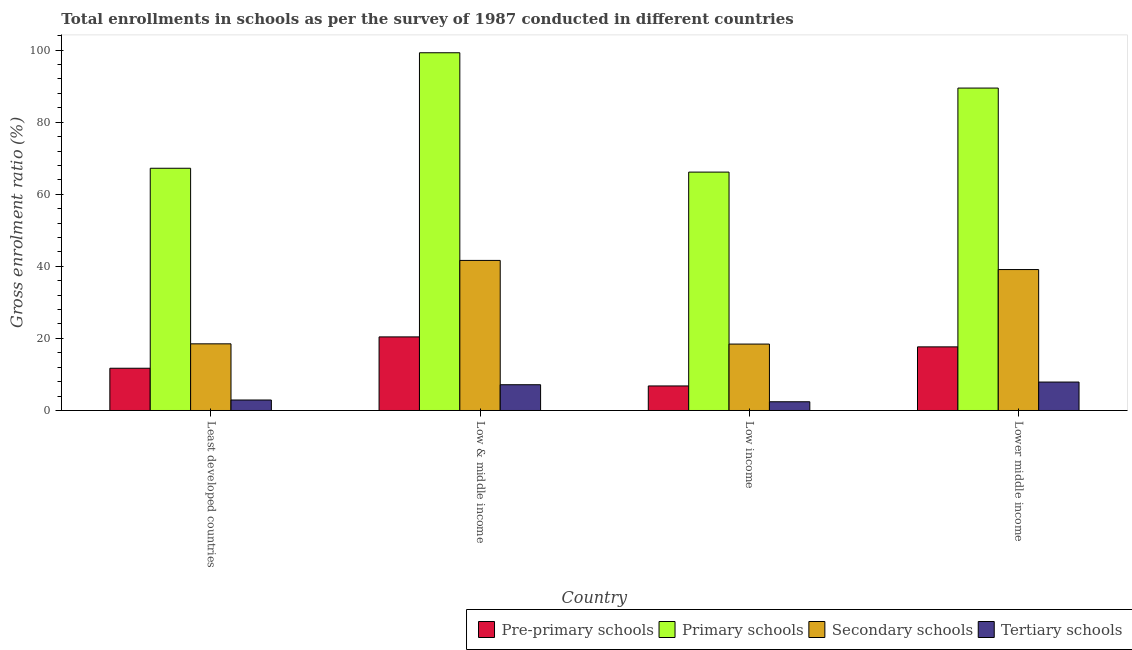What is the gross enrolment ratio in primary schools in Lower middle income?
Offer a terse response. 89.47. Across all countries, what is the maximum gross enrolment ratio in primary schools?
Provide a succinct answer. 99.26. Across all countries, what is the minimum gross enrolment ratio in primary schools?
Your answer should be compact. 66.15. In which country was the gross enrolment ratio in tertiary schools maximum?
Your answer should be compact. Lower middle income. What is the total gross enrolment ratio in primary schools in the graph?
Make the answer very short. 322.1. What is the difference between the gross enrolment ratio in pre-primary schools in Least developed countries and that in Low & middle income?
Provide a short and direct response. -8.7. What is the difference between the gross enrolment ratio in secondary schools in Low & middle income and the gross enrolment ratio in tertiary schools in Least developed countries?
Offer a terse response. 38.74. What is the average gross enrolment ratio in secondary schools per country?
Offer a very short reply. 29.42. What is the difference between the gross enrolment ratio in tertiary schools and gross enrolment ratio in pre-primary schools in Low & middle income?
Make the answer very short. -13.27. In how many countries, is the gross enrolment ratio in tertiary schools greater than 68 %?
Keep it short and to the point. 0. What is the ratio of the gross enrolment ratio in tertiary schools in Low income to that in Lower middle income?
Give a very brief answer. 0.31. Is the gross enrolment ratio in pre-primary schools in Least developed countries less than that in Low income?
Offer a very short reply. No. What is the difference between the highest and the second highest gross enrolment ratio in tertiary schools?
Give a very brief answer. 0.74. What is the difference between the highest and the lowest gross enrolment ratio in tertiary schools?
Ensure brevity in your answer.  5.47. Is it the case that in every country, the sum of the gross enrolment ratio in secondary schools and gross enrolment ratio in primary schools is greater than the sum of gross enrolment ratio in tertiary schools and gross enrolment ratio in pre-primary schools?
Give a very brief answer. Yes. What does the 1st bar from the left in Lower middle income represents?
Give a very brief answer. Pre-primary schools. What does the 1st bar from the right in Low & middle income represents?
Offer a terse response. Tertiary schools. Is it the case that in every country, the sum of the gross enrolment ratio in pre-primary schools and gross enrolment ratio in primary schools is greater than the gross enrolment ratio in secondary schools?
Offer a terse response. Yes. How many bars are there?
Make the answer very short. 16. Are all the bars in the graph horizontal?
Your answer should be compact. No. How many countries are there in the graph?
Provide a succinct answer. 4. What is the difference between two consecutive major ticks on the Y-axis?
Give a very brief answer. 20. Are the values on the major ticks of Y-axis written in scientific E-notation?
Give a very brief answer. No. Does the graph contain any zero values?
Offer a very short reply. No. What is the title of the graph?
Ensure brevity in your answer.  Total enrollments in schools as per the survey of 1987 conducted in different countries. Does "Secondary" appear as one of the legend labels in the graph?
Ensure brevity in your answer.  No. What is the label or title of the X-axis?
Offer a terse response. Country. What is the label or title of the Y-axis?
Make the answer very short. Gross enrolment ratio (%). What is the Gross enrolment ratio (%) in Pre-primary schools in Least developed countries?
Give a very brief answer. 11.72. What is the Gross enrolment ratio (%) of Primary schools in Least developed countries?
Ensure brevity in your answer.  67.22. What is the Gross enrolment ratio (%) in Secondary schools in Least developed countries?
Make the answer very short. 18.49. What is the Gross enrolment ratio (%) in Tertiary schools in Least developed countries?
Offer a terse response. 2.91. What is the Gross enrolment ratio (%) in Pre-primary schools in Low & middle income?
Your answer should be very brief. 20.42. What is the Gross enrolment ratio (%) of Primary schools in Low & middle income?
Provide a succinct answer. 99.26. What is the Gross enrolment ratio (%) in Secondary schools in Low & middle income?
Make the answer very short. 41.64. What is the Gross enrolment ratio (%) in Tertiary schools in Low & middle income?
Give a very brief answer. 7.15. What is the Gross enrolment ratio (%) of Pre-primary schools in Low income?
Offer a terse response. 6.81. What is the Gross enrolment ratio (%) of Primary schools in Low income?
Your answer should be very brief. 66.15. What is the Gross enrolment ratio (%) of Secondary schools in Low income?
Provide a short and direct response. 18.43. What is the Gross enrolment ratio (%) of Tertiary schools in Low income?
Offer a very short reply. 2.42. What is the Gross enrolment ratio (%) in Pre-primary schools in Lower middle income?
Offer a very short reply. 17.65. What is the Gross enrolment ratio (%) of Primary schools in Lower middle income?
Keep it short and to the point. 89.47. What is the Gross enrolment ratio (%) in Secondary schools in Lower middle income?
Give a very brief answer. 39.11. What is the Gross enrolment ratio (%) of Tertiary schools in Lower middle income?
Your response must be concise. 7.89. Across all countries, what is the maximum Gross enrolment ratio (%) of Pre-primary schools?
Provide a succinct answer. 20.42. Across all countries, what is the maximum Gross enrolment ratio (%) of Primary schools?
Your answer should be very brief. 99.26. Across all countries, what is the maximum Gross enrolment ratio (%) in Secondary schools?
Your answer should be very brief. 41.64. Across all countries, what is the maximum Gross enrolment ratio (%) in Tertiary schools?
Offer a very short reply. 7.89. Across all countries, what is the minimum Gross enrolment ratio (%) in Pre-primary schools?
Your answer should be compact. 6.81. Across all countries, what is the minimum Gross enrolment ratio (%) of Primary schools?
Your answer should be compact. 66.15. Across all countries, what is the minimum Gross enrolment ratio (%) of Secondary schools?
Offer a terse response. 18.43. Across all countries, what is the minimum Gross enrolment ratio (%) of Tertiary schools?
Keep it short and to the point. 2.42. What is the total Gross enrolment ratio (%) in Pre-primary schools in the graph?
Keep it short and to the point. 56.6. What is the total Gross enrolment ratio (%) in Primary schools in the graph?
Your answer should be compact. 322.1. What is the total Gross enrolment ratio (%) in Secondary schools in the graph?
Give a very brief answer. 117.68. What is the total Gross enrolment ratio (%) of Tertiary schools in the graph?
Your answer should be compact. 20.37. What is the difference between the Gross enrolment ratio (%) of Primary schools in Least developed countries and that in Low & middle income?
Your answer should be very brief. -32.05. What is the difference between the Gross enrolment ratio (%) in Secondary schools in Least developed countries and that in Low & middle income?
Your answer should be very brief. -23.15. What is the difference between the Gross enrolment ratio (%) of Tertiary schools in Least developed countries and that in Low & middle income?
Give a very brief answer. -4.24. What is the difference between the Gross enrolment ratio (%) of Pre-primary schools in Least developed countries and that in Low income?
Your answer should be compact. 4.91. What is the difference between the Gross enrolment ratio (%) of Primary schools in Least developed countries and that in Low income?
Your answer should be compact. 1.06. What is the difference between the Gross enrolment ratio (%) of Secondary schools in Least developed countries and that in Low income?
Keep it short and to the point. 0.06. What is the difference between the Gross enrolment ratio (%) of Tertiary schools in Least developed countries and that in Low income?
Ensure brevity in your answer.  0.48. What is the difference between the Gross enrolment ratio (%) in Pre-primary schools in Least developed countries and that in Lower middle income?
Offer a very short reply. -5.93. What is the difference between the Gross enrolment ratio (%) of Primary schools in Least developed countries and that in Lower middle income?
Your answer should be very brief. -22.25. What is the difference between the Gross enrolment ratio (%) in Secondary schools in Least developed countries and that in Lower middle income?
Give a very brief answer. -20.61. What is the difference between the Gross enrolment ratio (%) of Tertiary schools in Least developed countries and that in Lower middle income?
Your response must be concise. -4.98. What is the difference between the Gross enrolment ratio (%) of Pre-primary schools in Low & middle income and that in Low income?
Make the answer very short. 13.61. What is the difference between the Gross enrolment ratio (%) of Primary schools in Low & middle income and that in Low income?
Keep it short and to the point. 33.11. What is the difference between the Gross enrolment ratio (%) of Secondary schools in Low & middle income and that in Low income?
Keep it short and to the point. 23.21. What is the difference between the Gross enrolment ratio (%) in Tertiary schools in Low & middle income and that in Low income?
Your response must be concise. 4.72. What is the difference between the Gross enrolment ratio (%) of Pre-primary schools in Low & middle income and that in Lower middle income?
Provide a short and direct response. 2.77. What is the difference between the Gross enrolment ratio (%) of Primary schools in Low & middle income and that in Lower middle income?
Your response must be concise. 9.8. What is the difference between the Gross enrolment ratio (%) in Secondary schools in Low & middle income and that in Lower middle income?
Your answer should be very brief. 2.54. What is the difference between the Gross enrolment ratio (%) in Tertiary schools in Low & middle income and that in Lower middle income?
Offer a very short reply. -0.74. What is the difference between the Gross enrolment ratio (%) in Pre-primary schools in Low income and that in Lower middle income?
Provide a short and direct response. -10.84. What is the difference between the Gross enrolment ratio (%) in Primary schools in Low income and that in Lower middle income?
Your response must be concise. -23.31. What is the difference between the Gross enrolment ratio (%) in Secondary schools in Low income and that in Lower middle income?
Make the answer very short. -20.68. What is the difference between the Gross enrolment ratio (%) in Tertiary schools in Low income and that in Lower middle income?
Give a very brief answer. -5.47. What is the difference between the Gross enrolment ratio (%) in Pre-primary schools in Least developed countries and the Gross enrolment ratio (%) in Primary schools in Low & middle income?
Provide a short and direct response. -87.54. What is the difference between the Gross enrolment ratio (%) of Pre-primary schools in Least developed countries and the Gross enrolment ratio (%) of Secondary schools in Low & middle income?
Provide a succinct answer. -29.92. What is the difference between the Gross enrolment ratio (%) of Pre-primary schools in Least developed countries and the Gross enrolment ratio (%) of Tertiary schools in Low & middle income?
Ensure brevity in your answer.  4.57. What is the difference between the Gross enrolment ratio (%) of Primary schools in Least developed countries and the Gross enrolment ratio (%) of Secondary schools in Low & middle income?
Keep it short and to the point. 25.57. What is the difference between the Gross enrolment ratio (%) in Primary schools in Least developed countries and the Gross enrolment ratio (%) in Tertiary schools in Low & middle income?
Provide a succinct answer. 60.07. What is the difference between the Gross enrolment ratio (%) in Secondary schools in Least developed countries and the Gross enrolment ratio (%) in Tertiary schools in Low & middle income?
Your answer should be very brief. 11.35. What is the difference between the Gross enrolment ratio (%) of Pre-primary schools in Least developed countries and the Gross enrolment ratio (%) of Primary schools in Low income?
Make the answer very short. -54.43. What is the difference between the Gross enrolment ratio (%) in Pre-primary schools in Least developed countries and the Gross enrolment ratio (%) in Secondary schools in Low income?
Keep it short and to the point. -6.71. What is the difference between the Gross enrolment ratio (%) in Pre-primary schools in Least developed countries and the Gross enrolment ratio (%) in Tertiary schools in Low income?
Provide a short and direct response. 9.3. What is the difference between the Gross enrolment ratio (%) in Primary schools in Least developed countries and the Gross enrolment ratio (%) in Secondary schools in Low income?
Provide a succinct answer. 48.79. What is the difference between the Gross enrolment ratio (%) of Primary schools in Least developed countries and the Gross enrolment ratio (%) of Tertiary schools in Low income?
Ensure brevity in your answer.  64.79. What is the difference between the Gross enrolment ratio (%) of Secondary schools in Least developed countries and the Gross enrolment ratio (%) of Tertiary schools in Low income?
Ensure brevity in your answer.  16.07. What is the difference between the Gross enrolment ratio (%) of Pre-primary schools in Least developed countries and the Gross enrolment ratio (%) of Primary schools in Lower middle income?
Provide a short and direct response. -77.74. What is the difference between the Gross enrolment ratio (%) of Pre-primary schools in Least developed countries and the Gross enrolment ratio (%) of Secondary schools in Lower middle income?
Give a very brief answer. -27.39. What is the difference between the Gross enrolment ratio (%) in Pre-primary schools in Least developed countries and the Gross enrolment ratio (%) in Tertiary schools in Lower middle income?
Offer a very short reply. 3.83. What is the difference between the Gross enrolment ratio (%) of Primary schools in Least developed countries and the Gross enrolment ratio (%) of Secondary schools in Lower middle income?
Offer a terse response. 28.11. What is the difference between the Gross enrolment ratio (%) in Primary schools in Least developed countries and the Gross enrolment ratio (%) in Tertiary schools in Lower middle income?
Make the answer very short. 59.33. What is the difference between the Gross enrolment ratio (%) of Secondary schools in Least developed countries and the Gross enrolment ratio (%) of Tertiary schools in Lower middle income?
Provide a succinct answer. 10.6. What is the difference between the Gross enrolment ratio (%) in Pre-primary schools in Low & middle income and the Gross enrolment ratio (%) in Primary schools in Low income?
Your answer should be very brief. -45.73. What is the difference between the Gross enrolment ratio (%) in Pre-primary schools in Low & middle income and the Gross enrolment ratio (%) in Secondary schools in Low income?
Provide a succinct answer. 1.99. What is the difference between the Gross enrolment ratio (%) in Pre-primary schools in Low & middle income and the Gross enrolment ratio (%) in Tertiary schools in Low income?
Provide a short and direct response. 18. What is the difference between the Gross enrolment ratio (%) of Primary schools in Low & middle income and the Gross enrolment ratio (%) of Secondary schools in Low income?
Offer a terse response. 80.83. What is the difference between the Gross enrolment ratio (%) of Primary schools in Low & middle income and the Gross enrolment ratio (%) of Tertiary schools in Low income?
Offer a terse response. 96.84. What is the difference between the Gross enrolment ratio (%) of Secondary schools in Low & middle income and the Gross enrolment ratio (%) of Tertiary schools in Low income?
Provide a short and direct response. 39.22. What is the difference between the Gross enrolment ratio (%) of Pre-primary schools in Low & middle income and the Gross enrolment ratio (%) of Primary schools in Lower middle income?
Give a very brief answer. -69.04. What is the difference between the Gross enrolment ratio (%) in Pre-primary schools in Low & middle income and the Gross enrolment ratio (%) in Secondary schools in Lower middle income?
Ensure brevity in your answer.  -18.69. What is the difference between the Gross enrolment ratio (%) in Pre-primary schools in Low & middle income and the Gross enrolment ratio (%) in Tertiary schools in Lower middle income?
Keep it short and to the point. 12.53. What is the difference between the Gross enrolment ratio (%) in Primary schools in Low & middle income and the Gross enrolment ratio (%) in Secondary schools in Lower middle income?
Offer a very short reply. 60.16. What is the difference between the Gross enrolment ratio (%) of Primary schools in Low & middle income and the Gross enrolment ratio (%) of Tertiary schools in Lower middle income?
Give a very brief answer. 91.37. What is the difference between the Gross enrolment ratio (%) in Secondary schools in Low & middle income and the Gross enrolment ratio (%) in Tertiary schools in Lower middle income?
Offer a terse response. 33.75. What is the difference between the Gross enrolment ratio (%) in Pre-primary schools in Low income and the Gross enrolment ratio (%) in Primary schools in Lower middle income?
Offer a very short reply. -82.66. What is the difference between the Gross enrolment ratio (%) of Pre-primary schools in Low income and the Gross enrolment ratio (%) of Secondary schools in Lower middle income?
Offer a very short reply. -32.3. What is the difference between the Gross enrolment ratio (%) in Pre-primary schools in Low income and the Gross enrolment ratio (%) in Tertiary schools in Lower middle income?
Offer a very short reply. -1.08. What is the difference between the Gross enrolment ratio (%) of Primary schools in Low income and the Gross enrolment ratio (%) of Secondary schools in Lower middle income?
Give a very brief answer. 27.04. What is the difference between the Gross enrolment ratio (%) of Primary schools in Low income and the Gross enrolment ratio (%) of Tertiary schools in Lower middle income?
Your answer should be very brief. 58.26. What is the difference between the Gross enrolment ratio (%) of Secondary schools in Low income and the Gross enrolment ratio (%) of Tertiary schools in Lower middle income?
Give a very brief answer. 10.54. What is the average Gross enrolment ratio (%) in Pre-primary schools per country?
Keep it short and to the point. 14.15. What is the average Gross enrolment ratio (%) of Primary schools per country?
Your answer should be compact. 80.52. What is the average Gross enrolment ratio (%) of Secondary schools per country?
Provide a succinct answer. 29.42. What is the average Gross enrolment ratio (%) of Tertiary schools per country?
Your response must be concise. 5.09. What is the difference between the Gross enrolment ratio (%) in Pre-primary schools and Gross enrolment ratio (%) in Primary schools in Least developed countries?
Ensure brevity in your answer.  -55.49. What is the difference between the Gross enrolment ratio (%) in Pre-primary schools and Gross enrolment ratio (%) in Secondary schools in Least developed countries?
Your response must be concise. -6.77. What is the difference between the Gross enrolment ratio (%) of Pre-primary schools and Gross enrolment ratio (%) of Tertiary schools in Least developed countries?
Make the answer very short. 8.82. What is the difference between the Gross enrolment ratio (%) in Primary schools and Gross enrolment ratio (%) in Secondary schools in Least developed countries?
Provide a succinct answer. 48.72. What is the difference between the Gross enrolment ratio (%) in Primary schools and Gross enrolment ratio (%) in Tertiary schools in Least developed countries?
Offer a very short reply. 64.31. What is the difference between the Gross enrolment ratio (%) of Secondary schools and Gross enrolment ratio (%) of Tertiary schools in Least developed countries?
Your answer should be very brief. 15.59. What is the difference between the Gross enrolment ratio (%) in Pre-primary schools and Gross enrolment ratio (%) in Primary schools in Low & middle income?
Give a very brief answer. -78.84. What is the difference between the Gross enrolment ratio (%) of Pre-primary schools and Gross enrolment ratio (%) of Secondary schools in Low & middle income?
Keep it short and to the point. -21.22. What is the difference between the Gross enrolment ratio (%) in Pre-primary schools and Gross enrolment ratio (%) in Tertiary schools in Low & middle income?
Your answer should be compact. 13.27. What is the difference between the Gross enrolment ratio (%) of Primary schools and Gross enrolment ratio (%) of Secondary schools in Low & middle income?
Make the answer very short. 57.62. What is the difference between the Gross enrolment ratio (%) in Primary schools and Gross enrolment ratio (%) in Tertiary schools in Low & middle income?
Keep it short and to the point. 92.12. What is the difference between the Gross enrolment ratio (%) in Secondary schools and Gross enrolment ratio (%) in Tertiary schools in Low & middle income?
Offer a terse response. 34.5. What is the difference between the Gross enrolment ratio (%) in Pre-primary schools and Gross enrolment ratio (%) in Primary schools in Low income?
Keep it short and to the point. -59.34. What is the difference between the Gross enrolment ratio (%) in Pre-primary schools and Gross enrolment ratio (%) in Secondary schools in Low income?
Offer a terse response. -11.62. What is the difference between the Gross enrolment ratio (%) of Pre-primary schools and Gross enrolment ratio (%) of Tertiary schools in Low income?
Give a very brief answer. 4.39. What is the difference between the Gross enrolment ratio (%) of Primary schools and Gross enrolment ratio (%) of Secondary schools in Low income?
Keep it short and to the point. 47.72. What is the difference between the Gross enrolment ratio (%) in Primary schools and Gross enrolment ratio (%) in Tertiary schools in Low income?
Offer a terse response. 63.73. What is the difference between the Gross enrolment ratio (%) of Secondary schools and Gross enrolment ratio (%) of Tertiary schools in Low income?
Keep it short and to the point. 16.01. What is the difference between the Gross enrolment ratio (%) of Pre-primary schools and Gross enrolment ratio (%) of Primary schools in Lower middle income?
Give a very brief answer. -71.81. What is the difference between the Gross enrolment ratio (%) of Pre-primary schools and Gross enrolment ratio (%) of Secondary schools in Lower middle income?
Your answer should be compact. -21.46. What is the difference between the Gross enrolment ratio (%) of Pre-primary schools and Gross enrolment ratio (%) of Tertiary schools in Lower middle income?
Provide a short and direct response. 9.76. What is the difference between the Gross enrolment ratio (%) in Primary schools and Gross enrolment ratio (%) in Secondary schools in Lower middle income?
Offer a very short reply. 50.36. What is the difference between the Gross enrolment ratio (%) in Primary schools and Gross enrolment ratio (%) in Tertiary schools in Lower middle income?
Your response must be concise. 81.58. What is the difference between the Gross enrolment ratio (%) of Secondary schools and Gross enrolment ratio (%) of Tertiary schools in Lower middle income?
Keep it short and to the point. 31.22. What is the ratio of the Gross enrolment ratio (%) of Pre-primary schools in Least developed countries to that in Low & middle income?
Your answer should be very brief. 0.57. What is the ratio of the Gross enrolment ratio (%) of Primary schools in Least developed countries to that in Low & middle income?
Your answer should be very brief. 0.68. What is the ratio of the Gross enrolment ratio (%) of Secondary schools in Least developed countries to that in Low & middle income?
Provide a short and direct response. 0.44. What is the ratio of the Gross enrolment ratio (%) in Tertiary schools in Least developed countries to that in Low & middle income?
Keep it short and to the point. 0.41. What is the ratio of the Gross enrolment ratio (%) in Pre-primary schools in Least developed countries to that in Low income?
Provide a short and direct response. 1.72. What is the ratio of the Gross enrolment ratio (%) in Primary schools in Least developed countries to that in Low income?
Give a very brief answer. 1.02. What is the ratio of the Gross enrolment ratio (%) in Tertiary schools in Least developed countries to that in Low income?
Provide a short and direct response. 1.2. What is the ratio of the Gross enrolment ratio (%) of Pre-primary schools in Least developed countries to that in Lower middle income?
Your response must be concise. 0.66. What is the ratio of the Gross enrolment ratio (%) of Primary schools in Least developed countries to that in Lower middle income?
Offer a terse response. 0.75. What is the ratio of the Gross enrolment ratio (%) of Secondary schools in Least developed countries to that in Lower middle income?
Ensure brevity in your answer.  0.47. What is the ratio of the Gross enrolment ratio (%) in Tertiary schools in Least developed countries to that in Lower middle income?
Ensure brevity in your answer.  0.37. What is the ratio of the Gross enrolment ratio (%) in Pre-primary schools in Low & middle income to that in Low income?
Provide a succinct answer. 3. What is the ratio of the Gross enrolment ratio (%) of Primary schools in Low & middle income to that in Low income?
Keep it short and to the point. 1.5. What is the ratio of the Gross enrolment ratio (%) of Secondary schools in Low & middle income to that in Low income?
Provide a short and direct response. 2.26. What is the ratio of the Gross enrolment ratio (%) in Tertiary schools in Low & middle income to that in Low income?
Offer a terse response. 2.95. What is the ratio of the Gross enrolment ratio (%) of Pre-primary schools in Low & middle income to that in Lower middle income?
Make the answer very short. 1.16. What is the ratio of the Gross enrolment ratio (%) of Primary schools in Low & middle income to that in Lower middle income?
Offer a very short reply. 1.11. What is the ratio of the Gross enrolment ratio (%) of Secondary schools in Low & middle income to that in Lower middle income?
Your answer should be compact. 1.06. What is the ratio of the Gross enrolment ratio (%) in Tertiary schools in Low & middle income to that in Lower middle income?
Offer a very short reply. 0.91. What is the ratio of the Gross enrolment ratio (%) in Pre-primary schools in Low income to that in Lower middle income?
Offer a very short reply. 0.39. What is the ratio of the Gross enrolment ratio (%) of Primary schools in Low income to that in Lower middle income?
Give a very brief answer. 0.74. What is the ratio of the Gross enrolment ratio (%) of Secondary schools in Low income to that in Lower middle income?
Provide a succinct answer. 0.47. What is the ratio of the Gross enrolment ratio (%) of Tertiary schools in Low income to that in Lower middle income?
Your response must be concise. 0.31. What is the difference between the highest and the second highest Gross enrolment ratio (%) in Pre-primary schools?
Keep it short and to the point. 2.77. What is the difference between the highest and the second highest Gross enrolment ratio (%) of Primary schools?
Provide a succinct answer. 9.8. What is the difference between the highest and the second highest Gross enrolment ratio (%) in Secondary schools?
Ensure brevity in your answer.  2.54. What is the difference between the highest and the second highest Gross enrolment ratio (%) in Tertiary schools?
Your response must be concise. 0.74. What is the difference between the highest and the lowest Gross enrolment ratio (%) in Pre-primary schools?
Offer a terse response. 13.61. What is the difference between the highest and the lowest Gross enrolment ratio (%) in Primary schools?
Keep it short and to the point. 33.11. What is the difference between the highest and the lowest Gross enrolment ratio (%) in Secondary schools?
Your answer should be very brief. 23.21. What is the difference between the highest and the lowest Gross enrolment ratio (%) of Tertiary schools?
Your answer should be compact. 5.47. 